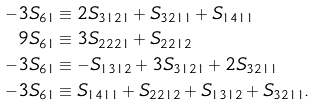Convert formula to latex. <formula><loc_0><loc_0><loc_500><loc_500>- 3 S _ { 6 1 } & \equiv 2 S _ { 3 1 2 1 } + S _ { 3 2 1 1 } + S _ { 1 4 1 1 } \\ 9 S _ { 6 1 } & \equiv 3 S _ { 2 2 2 1 } + S _ { 2 2 1 2 } \\ - 3 S _ { 6 1 } & \equiv - S _ { 1 3 1 2 } + 3 S _ { 3 1 2 1 } + 2 S _ { 3 2 1 1 } \\ - 3 S _ { 6 1 } & \equiv S _ { 1 4 1 1 } + S _ { 2 2 1 2 } + S _ { 1 3 1 2 } + S _ { 3 2 1 1 } .</formula> 